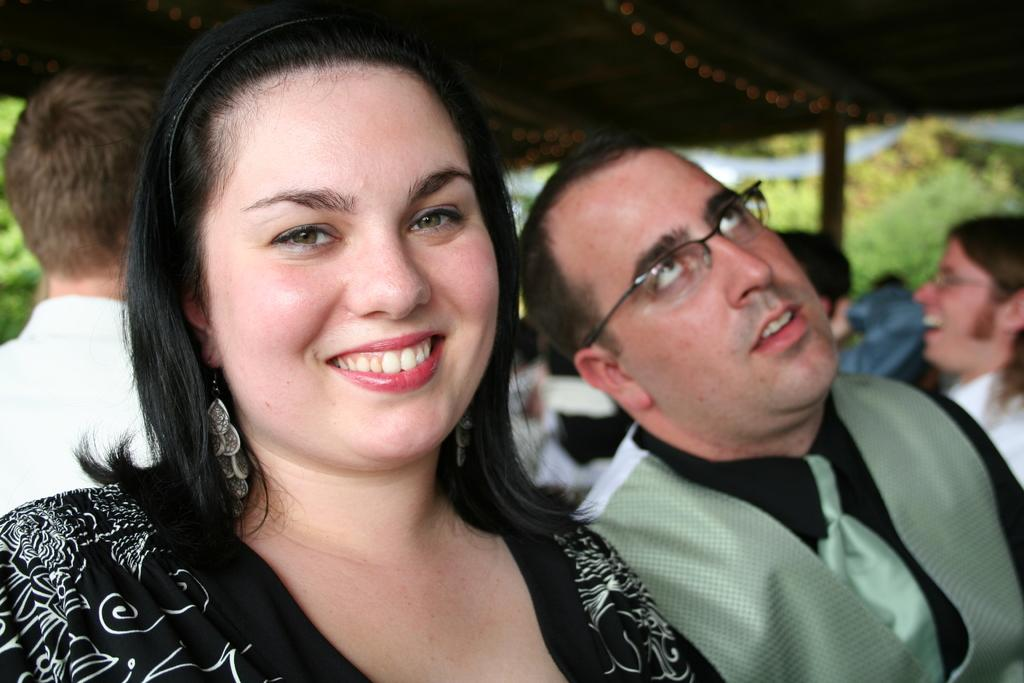Who is present in the image? There is a woman in the image. What is the woman doing in the image? The woman is smiling. Can you describe the person beside the woman? There is another person beside the woman, but their appearance or actions are not specified. What can be seen in the background of the image? There are people and trees in the background of the image. What type of jewel is the woman wearing in the image? There is no mention of any jewelry in the image, so it cannot be determined if the woman is wearing a jewel. 